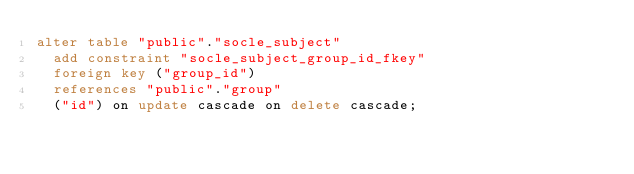Convert code to text. <code><loc_0><loc_0><loc_500><loc_500><_SQL_>alter table "public"."socle_subject"
  add constraint "socle_subject_group_id_fkey"
  foreign key ("group_id")
  references "public"."group"
  ("id") on update cascade on delete cascade;
</code> 